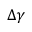Convert formula to latex. <formula><loc_0><loc_0><loc_500><loc_500>\Delta \gamma</formula> 